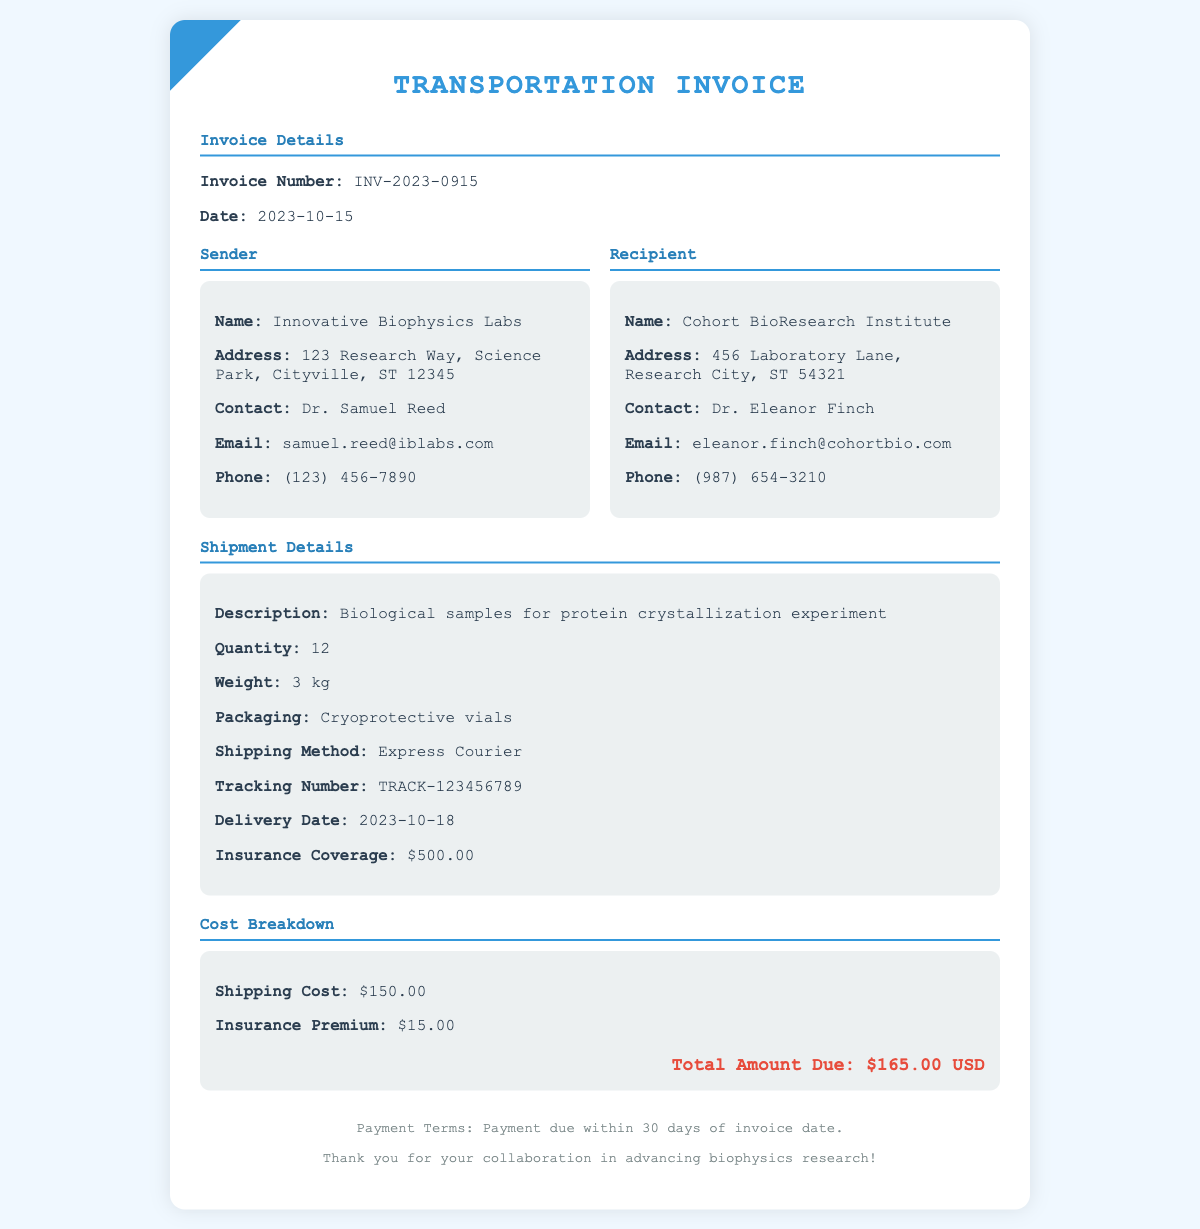What is the invoice number? The invoice number is specified in the document under 'Invoice Details' section as INV-2023-0915.
Answer: INV-2023-0915 What is the shipping method used? The shipping method is detailed in the 'Shipment Details' section as Express Courier.
Answer: Express Courier Who is the sender's contact person? The sender's contact person is listed in the 'Sender' section as Dr. Samuel Reed.
Answer: Dr. Samuel Reed What is the weight of the shipment? The weight of the shipment is mentioned in the 'Shipment Details' section as 3 kg.
Answer: 3 kg What is the total amount due? The total amount due is calculated in the 'Cost Breakdown' section, which sums up the shipping cost and insurance premium to be $165.00.
Answer: $165.00 When is the delivery date expected? The expected delivery date is provided in the 'Shipment Details' section as 2023-10-18.
Answer: 2023-10-18 What is the insurance coverage amount? The insurance coverage amount is specified in the 'Shipment Details' section as $500.00.
Answer: $500.00 Who is the recipient's contact person? The recipient's contact person is stated in the 'Recipient' section as Dr. Eleanor Finch.
Answer: Dr. Eleanor Finch What is the payment term specified in the document? The payment term is detailed in the footer of the document as payment due within 30 days of invoice date.
Answer: 30 days 